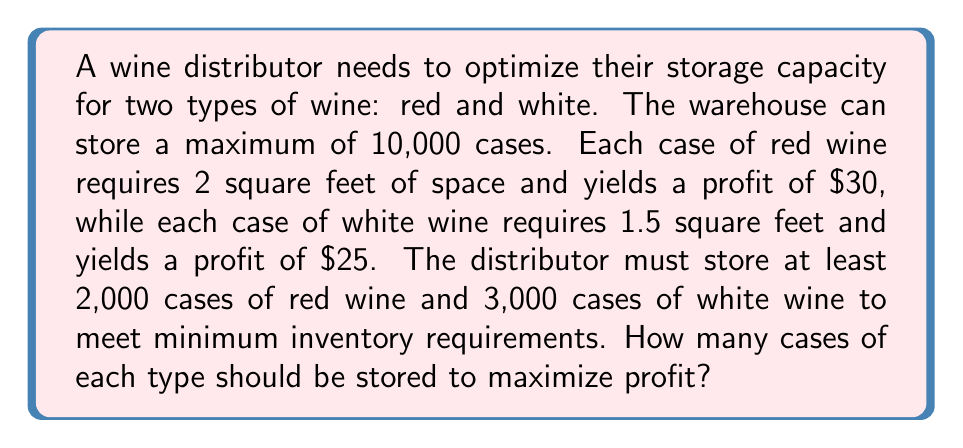Can you answer this question? Let's approach this problem using linear programming:

1. Define variables:
   $x$ = number of cases of red wine
   $y$ = number of cases of white wine

2. Objective function (maximize profit):
   $$ \text{Maximize } Z = 30x + 25y $$

3. Constraints:
   a) Storage space: $2x + 1.5y \leq 10000$
   b) Minimum red wine: $x \geq 2000$
   c) Minimum white wine: $y \geq 3000$
   d) Non-negativity: $x, y \geq 0$

4. Solve graphically or using the simplex method. In this case, we'll use the corner point method:

   Corner points:
   (2000, 3000): $Z = 60000 + 75000 = 135000$
   (2000, 4000): $Z = 60000 + 100000 = 160000$
   (3500, 3000): $Z = 105000 + 75000 = 180000$

   The optimal solution is at (3500, 3000)

5. Verify constraints:
   $2(3500) + 1.5(3000) = 7000 + 4500 = 11500 \leq 10000$ (Satisfied)
   $3500 \geq 2000$ (Satisfied)
   $3000 \geq 3000$ (Satisfied)

6. Adjust to meet storage constraint:
   $2x + 1.5y = 10000$
   $2(3500) + 1.5y = 10000$
   $7000 + 1.5y = 10000$
   $1.5y = 3000$
   $y = 2000$

   New solution: (3500, 2000)

7. Final profit:
   $Z = 30(3500) + 25(2000) = 105000 + 50000 = 155000$
Answer: 3,500 cases of red wine and 2,000 cases of white wine 